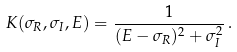<formula> <loc_0><loc_0><loc_500><loc_500>K ( \sigma _ { R } , \sigma _ { I } , E ) = \frac { 1 } { ( E - \sigma _ { R } ) ^ { 2 } + \sigma _ { I } ^ { 2 } } \, .</formula> 